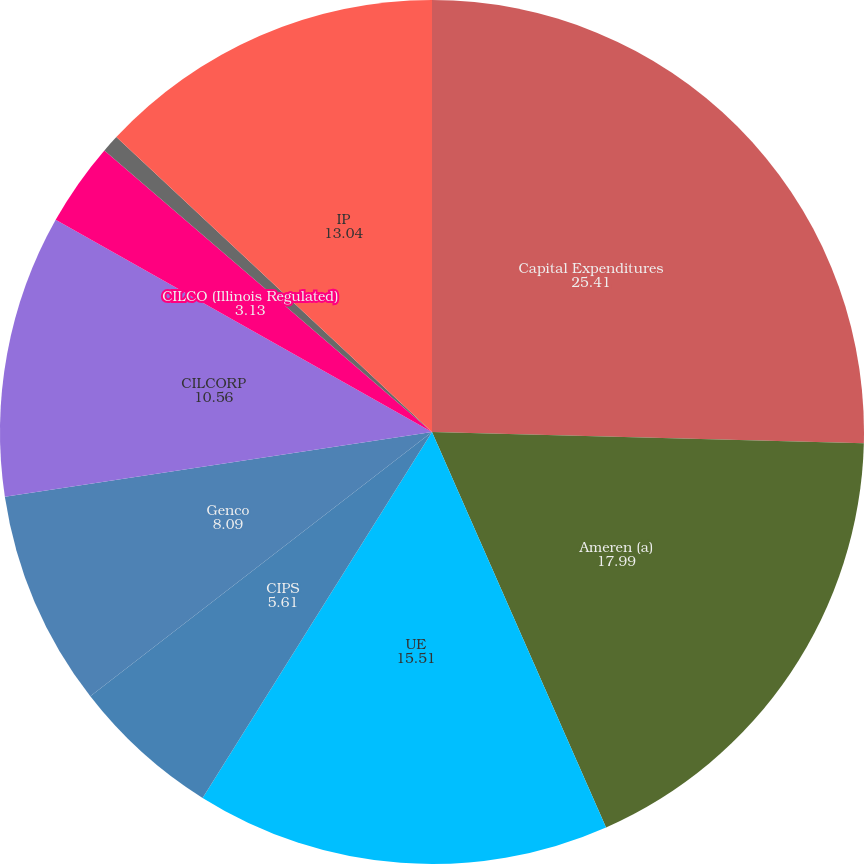<chart> <loc_0><loc_0><loc_500><loc_500><pie_chart><fcel>Capital Expenditures<fcel>Ameren (a)<fcel>UE<fcel>CIPS<fcel>Genco<fcel>CILCORP<fcel>CILCO (Illinois Regulated)<fcel>CILCO (AERG)<fcel>IP<nl><fcel>25.41%<fcel>17.99%<fcel>15.51%<fcel>5.61%<fcel>8.09%<fcel>10.56%<fcel>3.13%<fcel>0.66%<fcel>13.04%<nl></chart> 